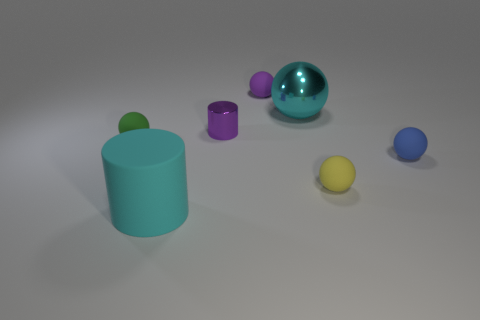What shape is the shiny object that is the same size as the green ball?
Make the answer very short. Cylinder. What is the small yellow ball made of?
Your answer should be compact. Rubber. There is a matte thing behind the big cyan thing right of the big thing that is in front of the tiny purple cylinder; what is its size?
Offer a terse response. Small. There is a object that is the same color as the large cylinder; what material is it?
Provide a succinct answer. Metal. What number of shiny things are yellow spheres or big cyan things?
Ensure brevity in your answer.  1. How big is the green object?
Your answer should be very brief. Small. How many things are either big red shiny cylinders or tiny matte spheres behind the small yellow thing?
Your answer should be very brief. 3. How many other things are the same color as the metal ball?
Your answer should be very brief. 1. Is the size of the yellow rubber sphere the same as the purple thing behind the cyan shiny thing?
Offer a very short reply. Yes. Is the size of the ball that is on the left side of the purple cylinder the same as the purple rubber sphere?
Your response must be concise. Yes. 